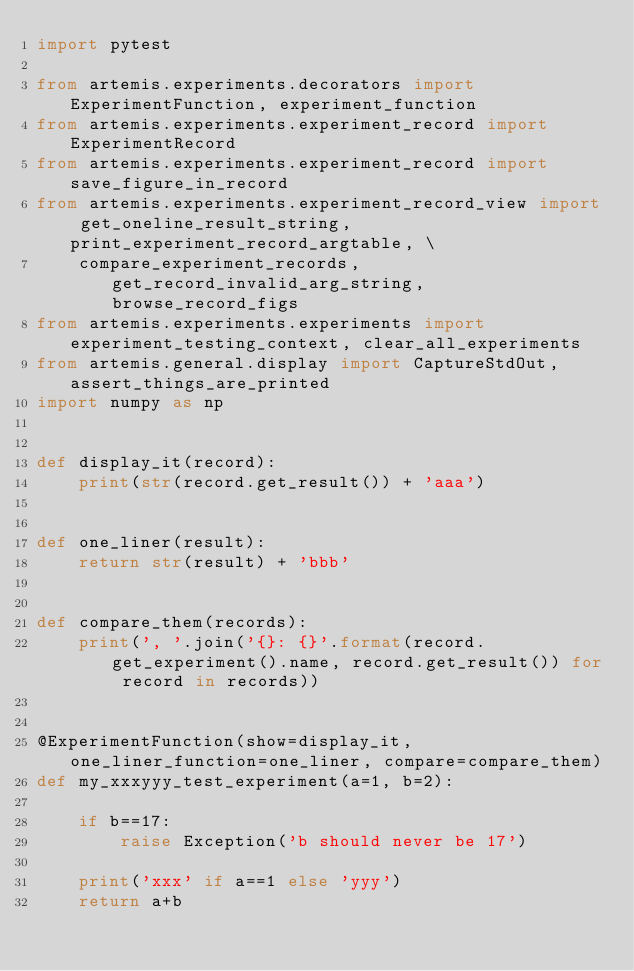<code> <loc_0><loc_0><loc_500><loc_500><_Python_>import pytest

from artemis.experiments.decorators import ExperimentFunction, experiment_function
from artemis.experiments.experiment_record import ExperimentRecord
from artemis.experiments.experiment_record import save_figure_in_record
from artemis.experiments.experiment_record_view import get_oneline_result_string, print_experiment_record_argtable, \
    compare_experiment_records, get_record_invalid_arg_string, browse_record_figs
from artemis.experiments.experiments import experiment_testing_context, clear_all_experiments
from artemis.general.display import CaptureStdOut, assert_things_are_printed
import numpy as np


def display_it(record):
    print(str(record.get_result()) + 'aaa')


def one_liner(result):
    return str(result) + 'bbb'


def compare_them(records):
    print(', '.join('{}: {}'.format(record.get_experiment().name, record.get_result()) for record in records))


@ExperimentFunction(show=display_it, one_liner_function=one_liner, compare=compare_them)
def my_xxxyyy_test_experiment(a=1, b=2):

    if b==17:
        raise Exception('b should never be 17')

    print('xxx' if a==1 else 'yyy')
    return a+b

</code> 